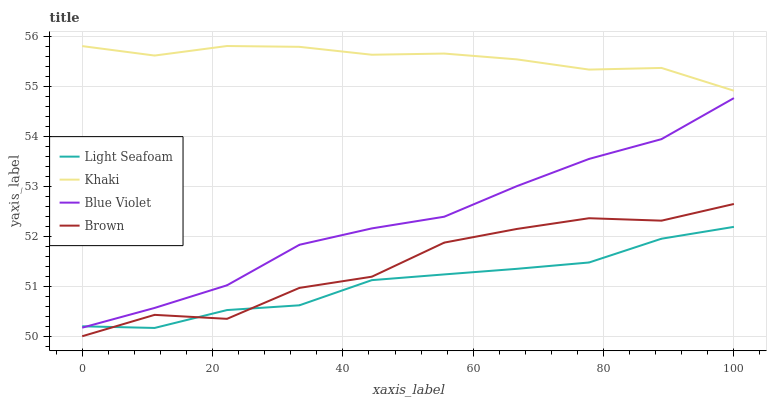Does Light Seafoam have the minimum area under the curve?
Answer yes or no. Yes. Does Khaki have the maximum area under the curve?
Answer yes or no. Yes. Does Khaki have the minimum area under the curve?
Answer yes or no. No. Does Light Seafoam have the maximum area under the curve?
Answer yes or no. No. Is Khaki the smoothest?
Answer yes or no. Yes. Is Brown the roughest?
Answer yes or no. Yes. Is Light Seafoam the smoothest?
Answer yes or no. No. Is Light Seafoam the roughest?
Answer yes or no. No. Does Brown have the lowest value?
Answer yes or no. Yes. Does Light Seafoam have the lowest value?
Answer yes or no. No. Does Khaki have the highest value?
Answer yes or no. Yes. Does Light Seafoam have the highest value?
Answer yes or no. No. Is Light Seafoam less than Khaki?
Answer yes or no. Yes. Is Blue Violet greater than Brown?
Answer yes or no. Yes. Does Blue Violet intersect Light Seafoam?
Answer yes or no. Yes. Is Blue Violet less than Light Seafoam?
Answer yes or no. No. Is Blue Violet greater than Light Seafoam?
Answer yes or no. No. Does Light Seafoam intersect Khaki?
Answer yes or no. No. 